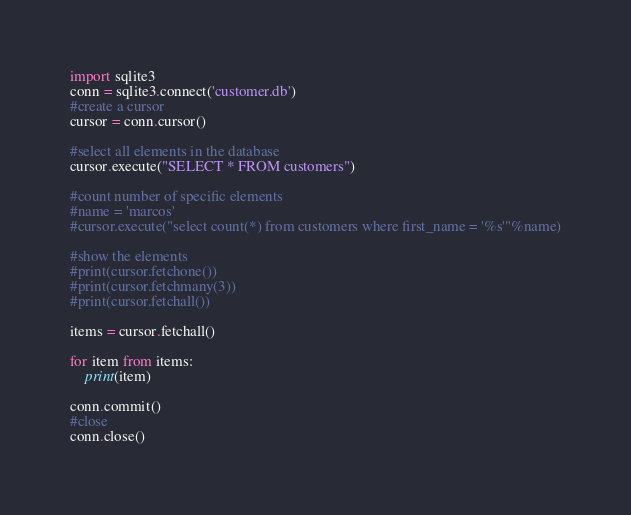Convert code to text. <code><loc_0><loc_0><loc_500><loc_500><_Python_>import sqlite3
conn = sqlite3.connect('customer.db')
#create a cursor
cursor = conn.cursor()

#select all elements in the database
cursor.execute("SELECT * FROM customers")

#count number of specific elements
#name = 'marcos'
#cursor.execute("select count(*) from customers where first_name = '%s'"%name)

#show the elements
#print(cursor.fetchone())
#print(cursor.fetchmany(3))
#print(cursor.fetchall())

items = cursor.fetchall()

for item from items:
    print(item)

conn.commit()
#close
conn.close()</code> 